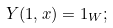Convert formula to latex. <formula><loc_0><loc_0><loc_500><loc_500>Y ( 1 , x ) = 1 _ { W } ;</formula> 